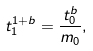Convert formula to latex. <formula><loc_0><loc_0><loc_500><loc_500>t _ { 1 } ^ { 1 + b } = \frac { t _ { 0 } ^ { b } } { m _ { 0 } } ,</formula> 